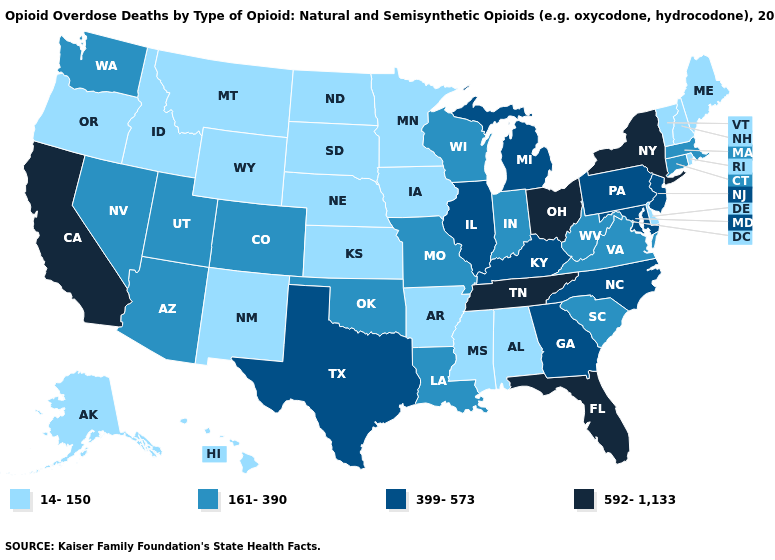Does Washington have a lower value than California?
Keep it brief. Yes. What is the lowest value in the MidWest?
Short answer required. 14-150. How many symbols are there in the legend?
Keep it brief. 4. What is the value of North Carolina?
Concise answer only. 399-573. Does Tennessee have the highest value in the USA?
Give a very brief answer. Yes. What is the value of Maryland?
Concise answer only. 399-573. Among the states that border Minnesota , which have the lowest value?
Short answer required. Iowa, North Dakota, South Dakota. Among the states that border Florida , which have the highest value?
Give a very brief answer. Georgia. Among the states that border Connecticut , which have the highest value?
Keep it brief. New York. Which states have the lowest value in the USA?
Be succinct. Alabama, Alaska, Arkansas, Delaware, Hawaii, Idaho, Iowa, Kansas, Maine, Minnesota, Mississippi, Montana, Nebraska, New Hampshire, New Mexico, North Dakota, Oregon, Rhode Island, South Dakota, Vermont, Wyoming. What is the highest value in the West ?
Answer briefly. 592-1,133. Which states hav the highest value in the South?
Quick response, please. Florida, Tennessee. Name the states that have a value in the range 592-1,133?
Answer briefly. California, Florida, New York, Ohio, Tennessee. What is the lowest value in states that border Minnesota?
Write a very short answer. 14-150. 